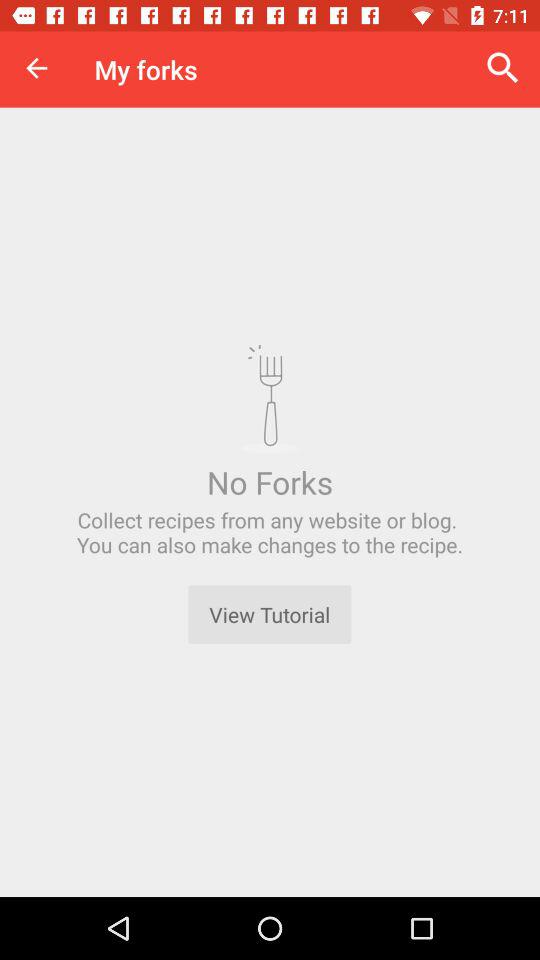Are there any forks? There are no forks. 